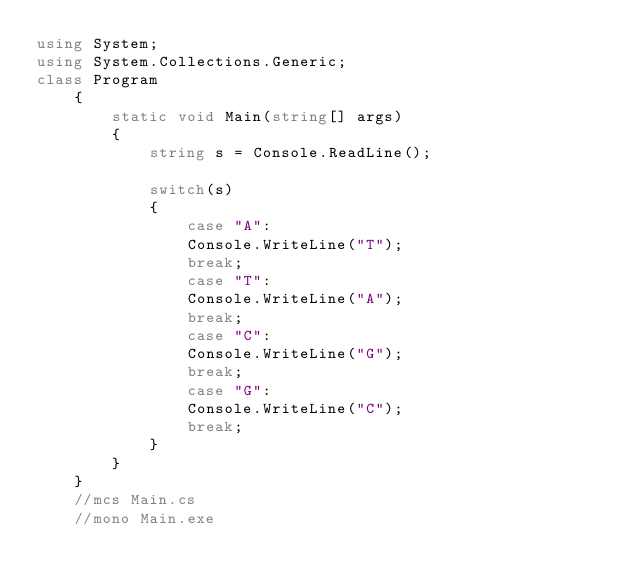<code> <loc_0><loc_0><loc_500><loc_500><_C#_>using System;
using System.Collections.Generic;
class Program
    {
    	static void Main(string[] args)
    	{
            string s = Console.ReadLine();
            
            switch(s)
            {
                case "A":
                Console.WriteLine("T");
                break;
                case "T":
                Console.WriteLine("A");
                break;
                case "C":
                Console.WriteLine("G");
                break;
                case "G":
                Console.WriteLine("C");
                break;
            }
        }
    }
    //mcs Main.cs
    //mono Main.exe</code> 